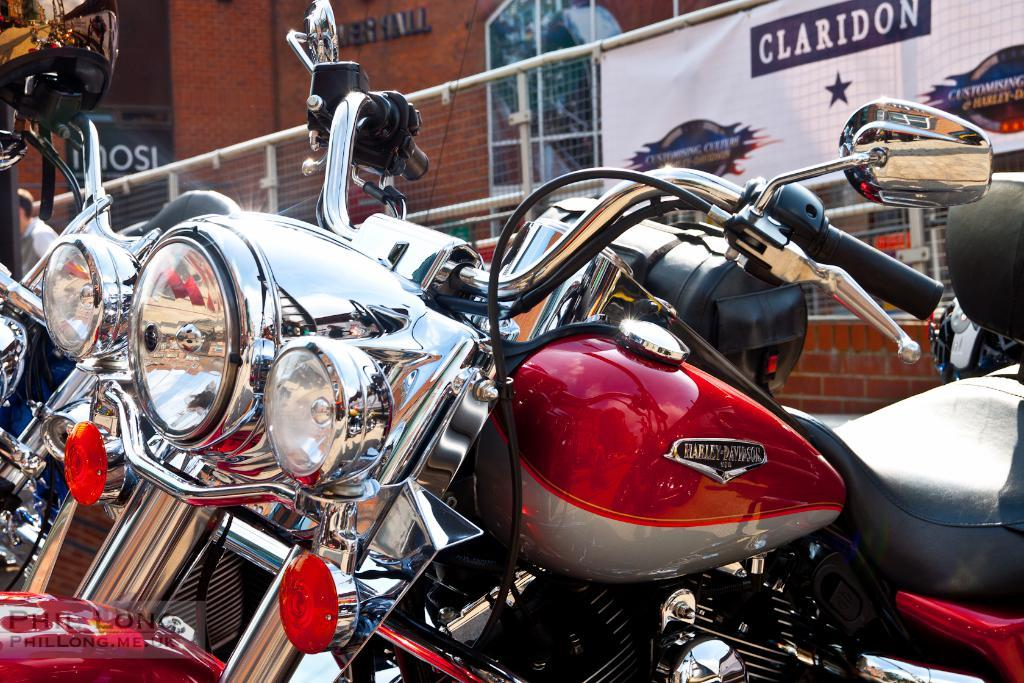What can be seen in the image? There are vehicles in the image. How are the vehicles arranged in the image? The vehicles are parked one beside another. Where are the vehicles located in relation to a building? The vehicles are in front of a showroom. What is the condition of the vehicles in the image? The vehicles are new and sealed. Can you see any water flowing through the wires in the image? There are no wires or water present in the image. 